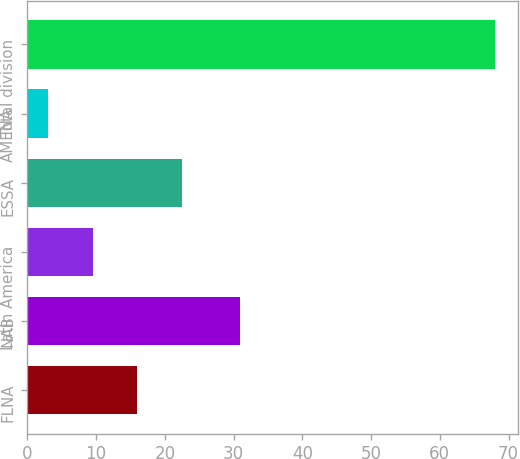<chart> <loc_0><loc_0><loc_500><loc_500><bar_chart><fcel>FLNA<fcel>NAB<fcel>Latin America<fcel>ESSA<fcel>AMENA<fcel>Total division<nl><fcel>16<fcel>31<fcel>9.5<fcel>22.5<fcel>3<fcel>68<nl></chart> 